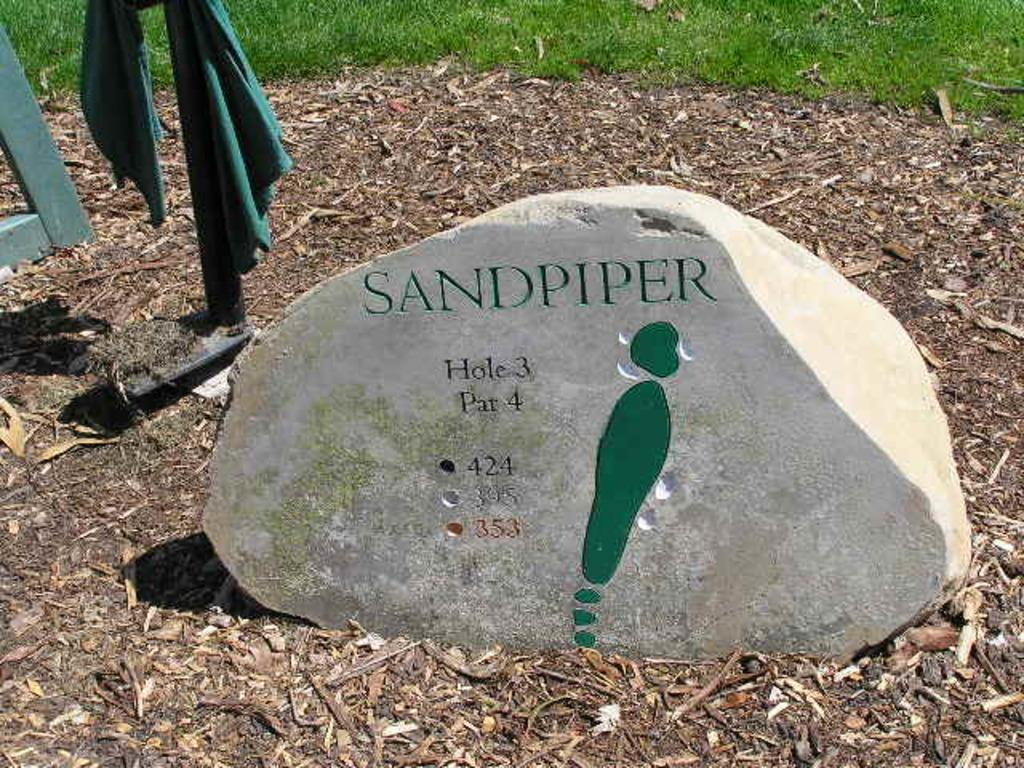What is on the stone in the image? There is text on the stone in the image. What can be found on the ground in the image? Dry leaves are present on the ground. What is attached to the pole in the image? There is a cloth attached to a pole. What object made of wood is visible in the image? A wooden stick is visible in the image. What type of vegetation is visible in the background of the image? Grass is present in the background of the image. Who is the owner of the chicken in the image? There is no chicken present in the image. What type of coat is the person wearing in the image? There is no person or coat visible in the image. 